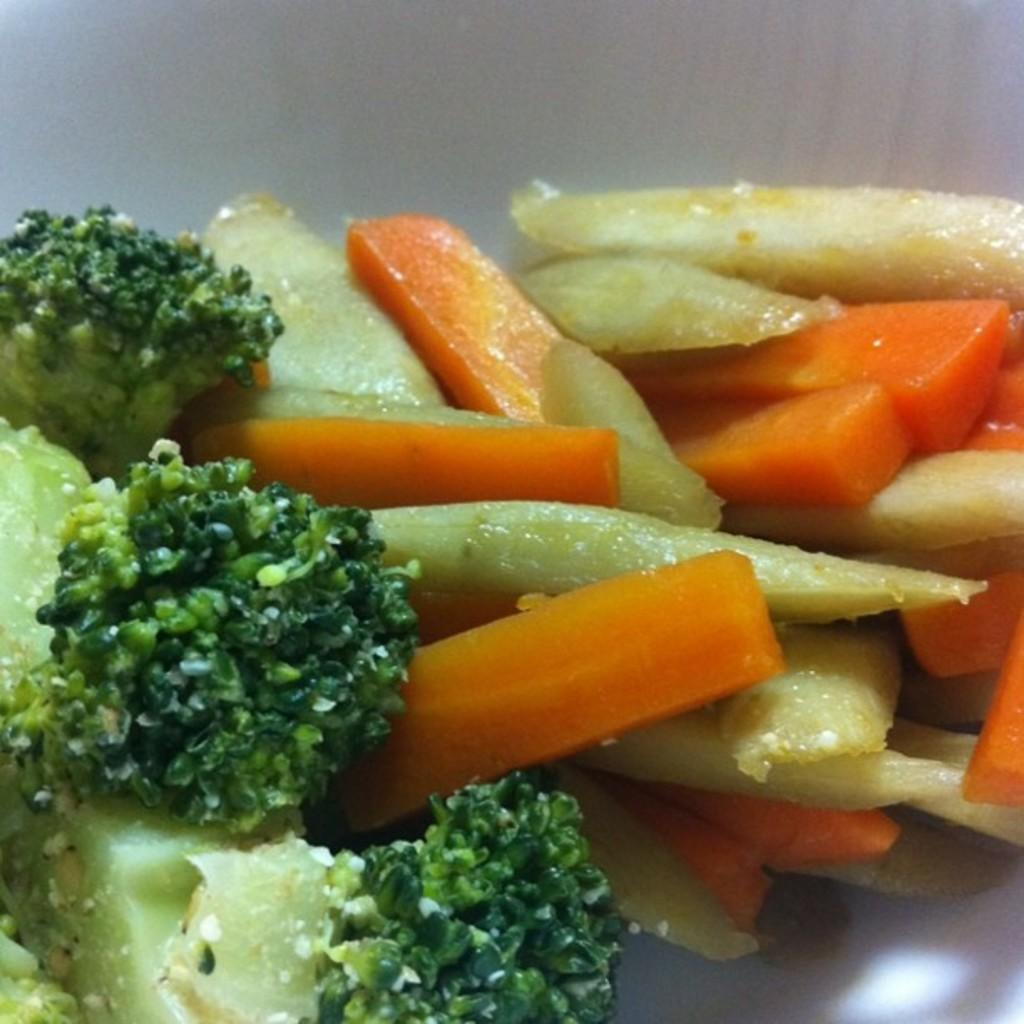What is the main object in the image? There is a box in the image. What is inside the box? The box contains french fries, carrot slices, and broccoli. What advice does the uncle give during the journey in the image? There is no uncle or journey present in the image; it only features a box with french fries, carrot slices, and broccoli. 